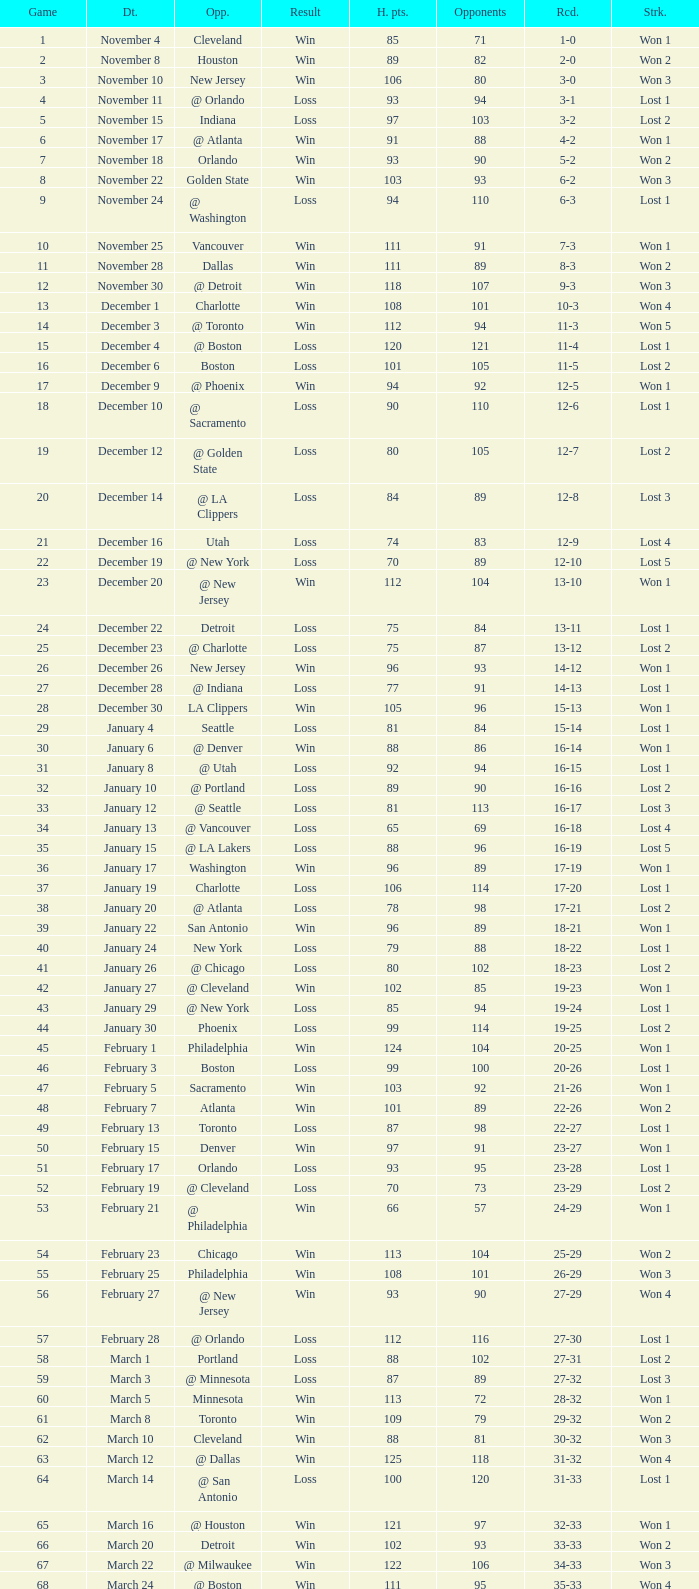What is the highest Game, when Opponents is less than 80, and when Record is "1-0"? 1.0. 